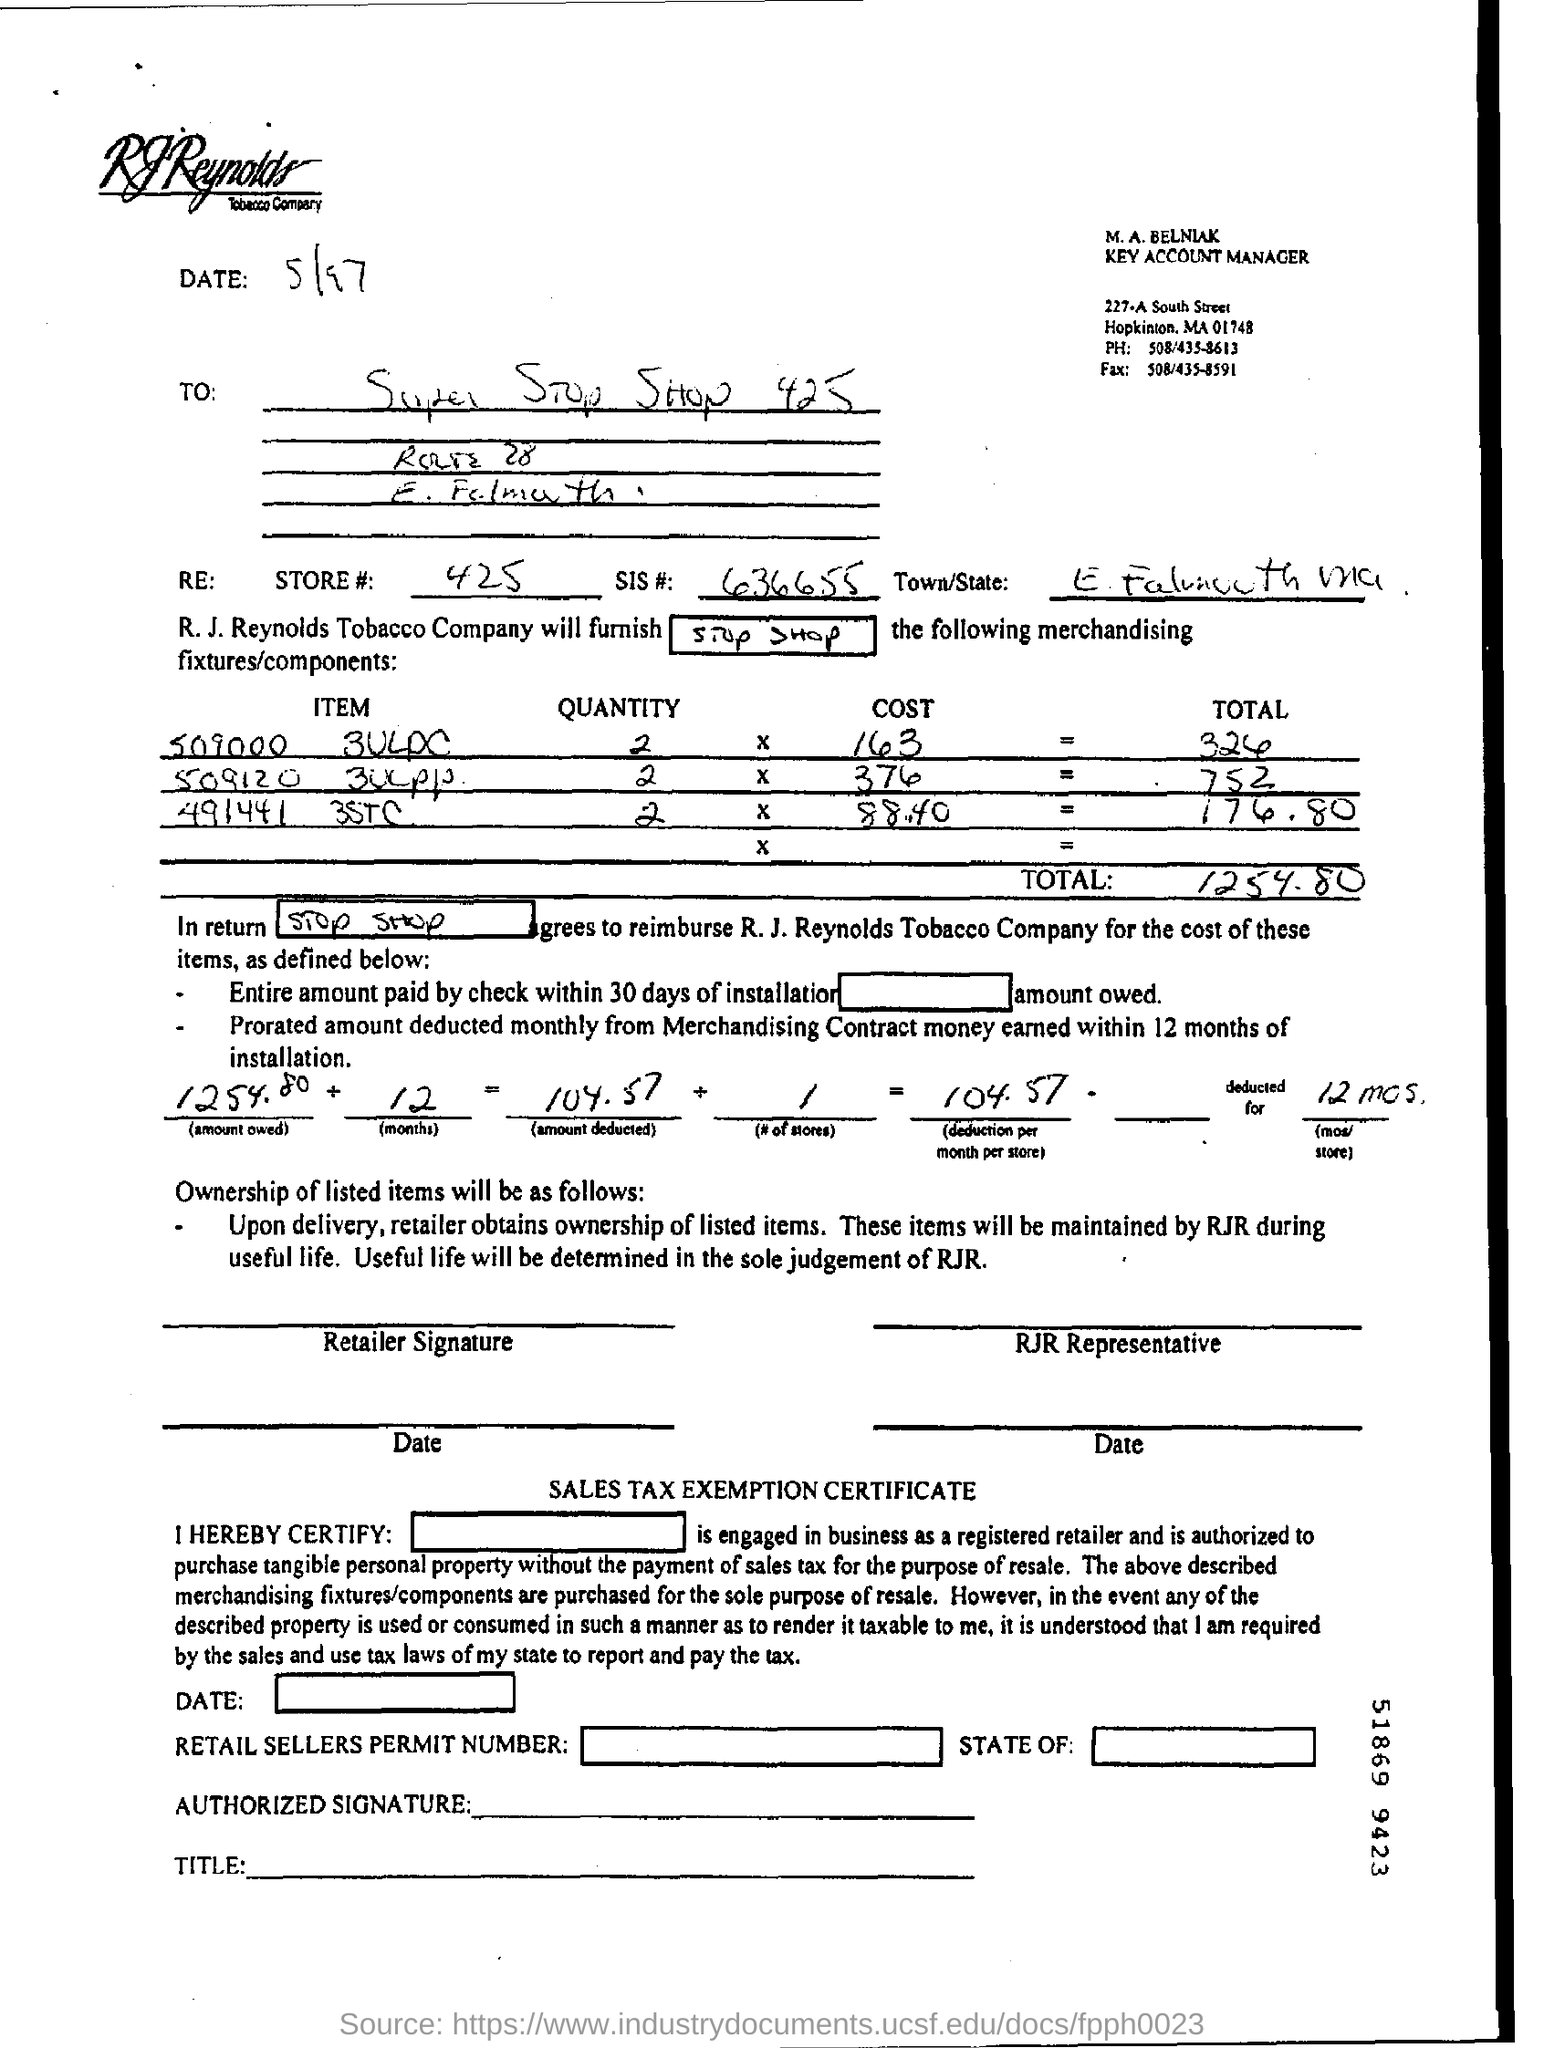What is SIS #?
Give a very brief answer. 636655. What is the total cost?
Ensure brevity in your answer.  1254.80. What is the date mentioned in this document?
Offer a terse response. 5/97. 